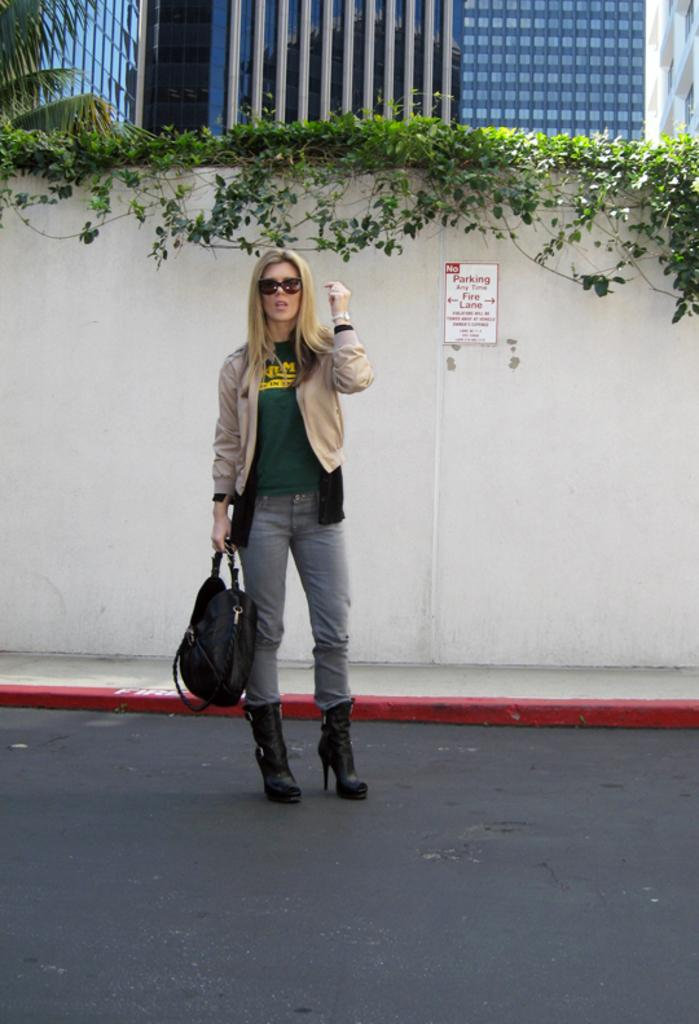Who is present in the image? There is a woman in the image. Where is the woman located in the image? The woman is standing in the middle of the image. What is the woman carrying in the image? The woman is carrying a bag. What can be seen on the wall in the image? The wall has a parking note on it. What is visible behind the wall in the image? There are buildings and a tree visible behind the wall. What type of aftermath can be seen in the image? There is no indication of any aftermath in the image; it simply shows a woman standing with a bag, a wall with a parking note, and buildings and a tree in the background. How many ducks are visible on top of the wall in the image? There are no ducks present in the image, and the wall is not mentioned as having any ducks on top of it. 